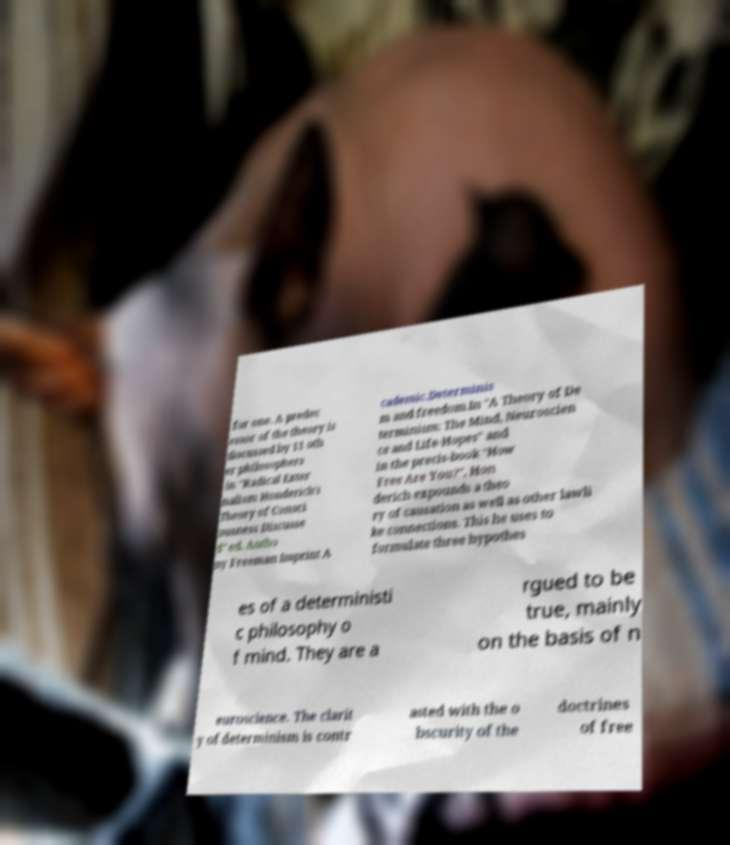Please identify and transcribe the text found in this image. for one. A predec essor of the theory is discussed by 11 oth er philosophers in "Radical Exter nalism Honderich's Theory of Consci ousness Discusse d" ed. Antho ny Freeman Imprint A cademic.Determinis m and freedom.In "A Theory of De terminism: The Mind, Neuroscien ce and Life-Hopes" and in the precis-book "How Free Are You?", Hon derich expounds a theo ry of causation as well as other lawli ke connections. This he uses to formulate three hypothes es of a deterministi c philosophy o f mind. They are a rgued to be true, mainly on the basis of n euroscience. The clarit y of determinism is contr asted with the o bscurity of the doctrines of free 